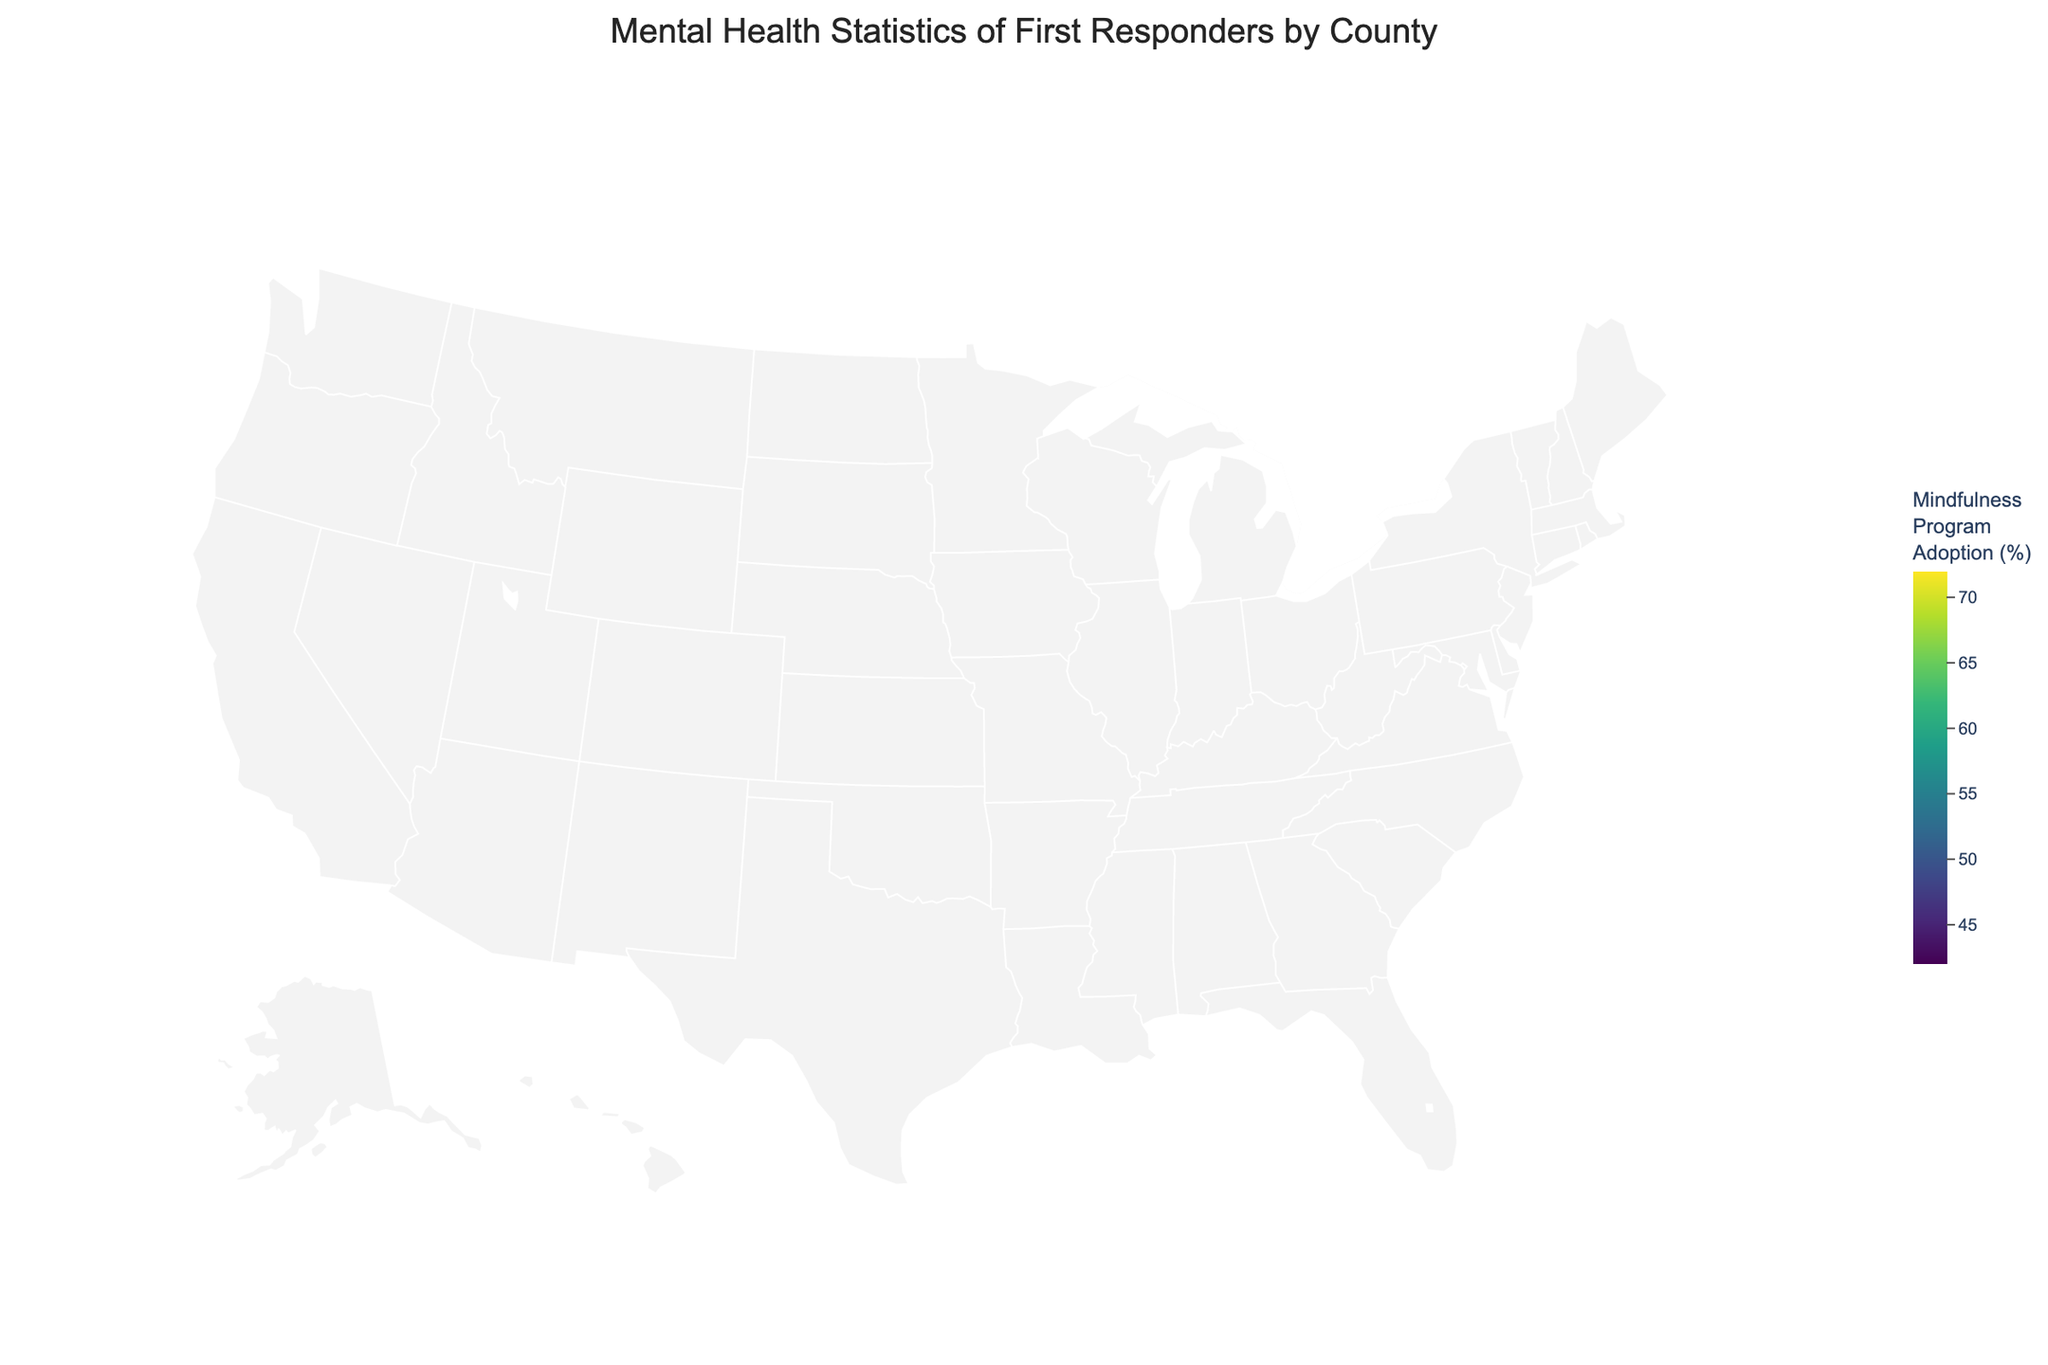How many counties are represented in the figure? Count the number of distinct counties listed in the data.
Answer: 10 Which county has the highest rate of mindfulness program adoption? Look for the county with the highest percentage in the "Mindfulness_Program_Adoption" column in the data.
Answer: King What is the average PTSD rate across all counties? Sum the PTSD rates for all counties and divide by the number of counties: (18.5 + 17.9 + 16.2 + 15.8 + 14.9 + 19.1 + 18.3 + 17.6 + 16.7 + 15.3) / 10 = 17.03
Answer: 17.03% Which county has the lowest depression rate, and what is that rate? Identify the county with the smallest percentage in the "Depression_Rate" column in the data.
Answer: King, 18.5% How does the anxiety rate in Cook County compare to that in Harris County? Refer to the "Anxiety_Rate" column for both Cook and Harris counties and compare: Cook (24.5%) vs. Harris (23.9%).
Answer: Cook has a higher anxiety rate Which counties have a PTSD rate that is higher than the average PTSD rate calculated earlier? Use the earlier calculated average PTSD rate (17.03%). Check each county's PTSD rate against this average: Los Angeles (18.5%), Cook (17.9%), Philadelphia (18.3%), Miami-Dade (19.1%).
Answer: Los Angeles, Cook, Philadelphia, Miami-Dade What relationship, if any, can be observed between mindfulness program adoption rates and PTSD rates? Analyze the scatter plot to observe the distribution of PTSD rates relative to mindfulness program adoption rates. Generally, counties with higher mindfulness program adoption tend to have slightly lower PTSD rates.
Answer: Higher mindfulness adoption correlates with slightly lower PTSD rates Which county's mental health statistics are represented with the largest circle on the map, indicating the highest PTSD rate? Identify the county with the largest circle, representing the highest PTSD rate: Miami-Dade (19.1%).
Answer: Miami-Dade Considering both depression and anxiety rates, which county shows the highest combined rate? Sum the depression and anxiety rates for each county and identify the highest sum: Los Angeles (22.3 + 25.7 = 48.0).
Answer: Los Angeles 